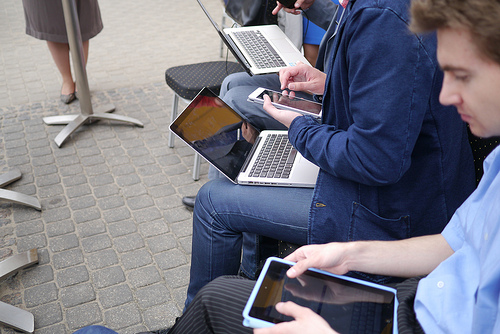Please provide a short description for this region: [0.38, 0.18, 0.62, 0.3]. This region depicts a person holding a portable computer, possibly discussing content visible on the screen with nearby individuals. 